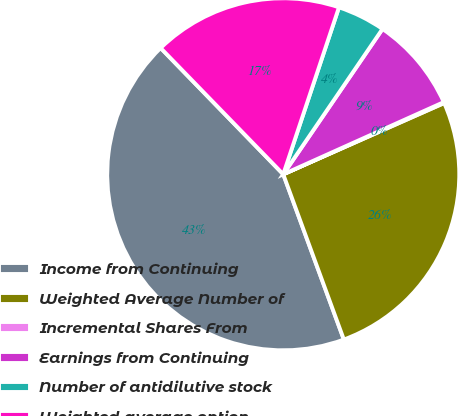<chart> <loc_0><loc_0><loc_500><loc_500><pie_chart><fcel>Income from Continuing<fcel>Weighted Average Number of<fcel>Incremental Shares From<fcel>Earnings from Continuing<fcel>Number of antidilutive stock<fcel>Weighted average option<nl><fcel>43.33%<fcel>26.04%<fcel>0.09%<fcel>8.74%<fcel>4.41%<fcel>17.39%<nl></chart> 